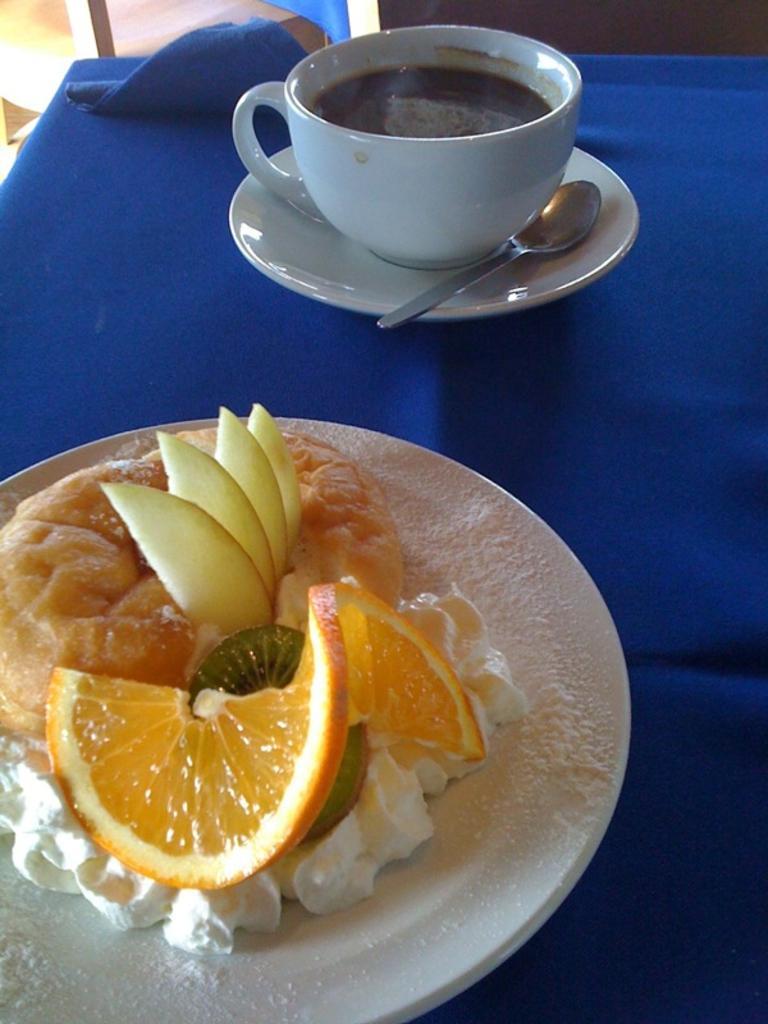Can you describe this image briefly? This is the picture of a table on which there is a plate which has a cup and a spoon and to the side there is plate in which there are some fruits, cream and some other things. 